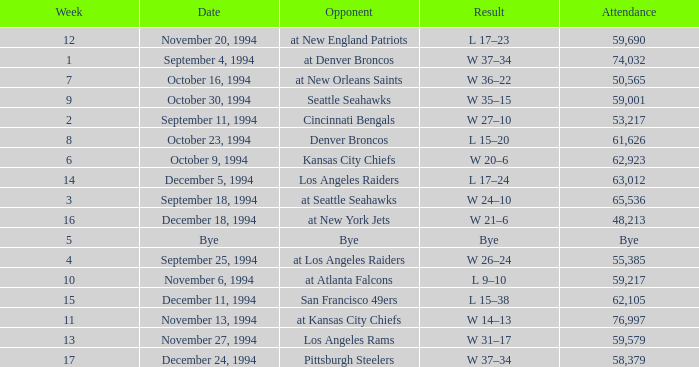In the game where they played the Pittsburgh Steelers, what was the attendance? 58379.0. 